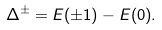Convert formula to latex. <formula><loc_0><loc_0><loc_500><loc_500>\Delta ^ { \pm } = E ( \pm 1 ) - E ( 0 ) .</formula> 